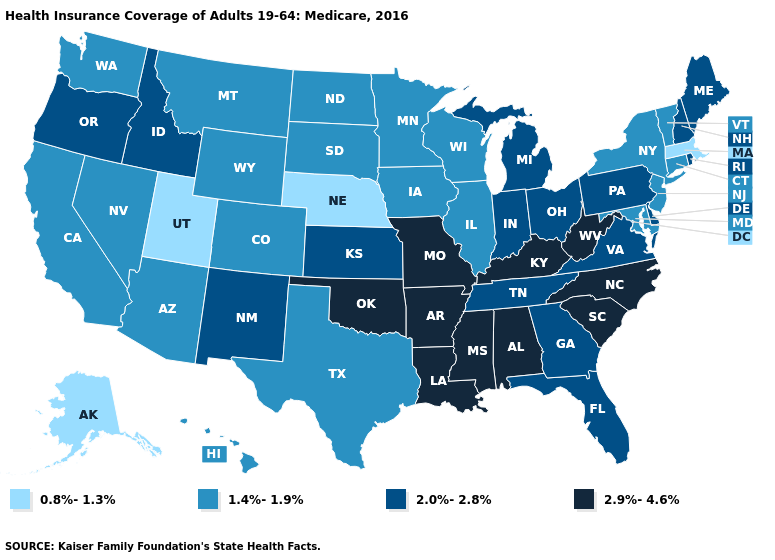Among the states that border Nebraska , which have the highest value?
Short answer required. Missouri. Does Maryland have the highest value in the South?
Concise answer only. No. What is the highest value in the USA?
Answer briefly. 2.9%-4.6%. Which states have the lowest value in the USA?
Concise answer only. Alaska, Massachusetts, Nebraska, Utah. What is the value of Washington?
Be succinct. 1.4%-1.9%. Name the states that have a value in the range 2.9%-4.6%?
Short answer required. Alabama, Arkansas, Kentucky, Louisiana, Mississippi, Missouri, North Carolina, Oklahoma, South Carolina, West Virginia. Does the map have missing data?
Keep it brief. No. Does Mississippi have a higher value than North Dakota?
Short answer required. Yes. Is the legend a continuous bar?
Write a very short answer. No. Name the states that have a value in the range 0.8%-1.3%?
Keep it brief. Alaska, Massachusetts, Nebraska, Utah. Name the states that have a value in the range 2.0%-2.8%?
Keep it brief. Delaware, Florida, Georgia, Idaho, Indiana, Kansas, Maine, Michigan, New Hampshire, New Mexico, Ohio, Oregon, Pennsylvania, Rhode Island, Tennessee, Virginia. Does Florida have the lowest value in the South?
Give a very brief answer. No. Name the states that have a value in the range 0.8%-1.3%?
Concise answer only. Alaska, Massachusetts, Nebraska, Utah. What is the highest value in states that border Oklahoma?
Quick response, please. 2.9%-4.6%. Does Massachusetts have the lowest value in the Northeast?
Answer briefly. Yes. 